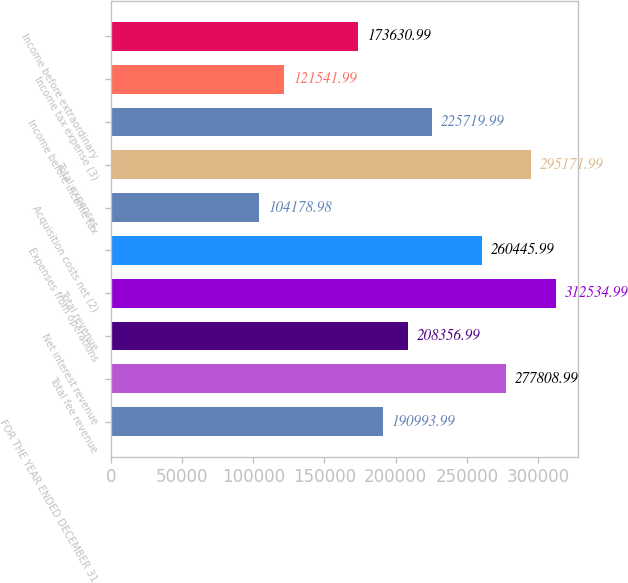<chart> <loc_0><loc_0><loc_500><loc_500><bar_chart><fcel>FOR THE YEAR ENDED DECEMBER 31<fcel>Total fee revenue<fcel>Net interest revenue<fcel>Total revenue<fcel>Expenses from operations<fcel>Acquisition costs net (2)<fcel>Total expenses<fcel>Income before income tax<fcel>Income tax expense (3)<fcel>Income before extraordinary<nl><fcel>190994<fcel>277809<fcel>208357<fcel>312535<fcel>260446<fcel>104179<fcel>295172<fcel>225720<fcel>121542<fcel>173631<nl></chart> 